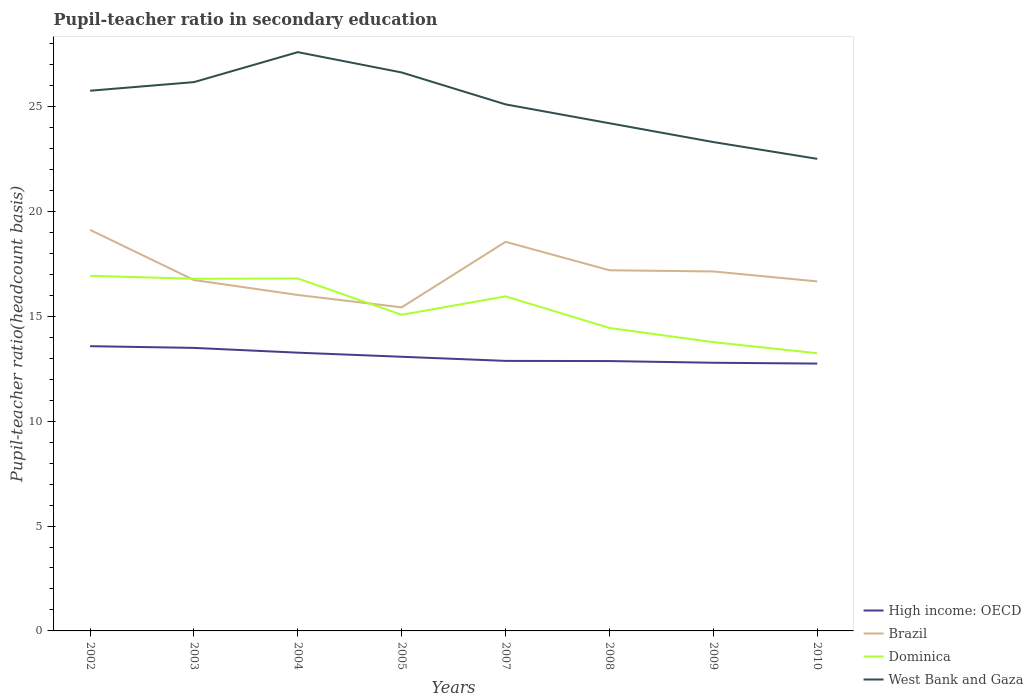How many different coloured lines are there?
Your answer should be very brief. 4. Across all years, what is the maximum pupil-teacher ratio in secondary education in Dominica?
Provide a succinct answer. 13.24. What is the total pupil-teacher ratio in secondary education in Dominica in the graph?
Your answer should be compact. 0.13. What is the difference between the highest and the second highest pupil-teacher ratio in secondary education in West Bank and Gaza?
Ensure brevity in your answer.  5.09. What is the difference between the highest and the lowest pupil-teacher ratio in secondary education in High income: OECD?
Provide a succinct answer. 3. How many lines are there?
Your answer should be very brief. 4. What is the difference between two consecutive major ticks on the Y-axis?
Offer a terse response. 5. Are the values on the major ticks of Y-axis written in scientific E-notation?
Ensure brevity in your answer.  No. What is the title of the graph?
Make the answer very short. Pupil-teacher ratio in secondary education. Does "Small states" appear as one of the legend labels in the graph?
Ensure brevity in your answer.  No. What is the label or title of the X-axis?
Offer a terse response. Years. What is the label or title of the Y-axis?
Keep it short and to the point. Pupil-teacher ratio(headcount basis). What is the Pupil-teacher ratio(headcount basis) of High income: OECD in 2002?
Provide a short and direct response. 13.58. What is the Pupil-teacher ratio(headcount basis) in Brazil in 2002?
Your answer should be compact. 19.12. What is the Pupil-teacher ratio(headcount basis) of Dominica in 2002?
Your answer should be very brief. 16.93. What is the Pupil-teacher ratio(headcount basis) in West Bank and Gaza in 2002?
Keep it short and to the point. 25.76. What is the Pupil-teacher ratio(headcount basis) in High income: OECD in 2003?
Your response must be concise. 13.49. What is the Pupil-teacher ratio(headcount basis) in Brazil in 2003?
Keep it short and to the point. 16.73. What is the Pupil-teacher ratio(headcount basis) of Dominica in 2003?
Keep it short and to the point. 16.79. What is the Pupil-teacher ratio(headcount basis) in West Bank and Gaza in 2003?
Provide a succinct answer. 26.17. What is the Pupil-teacher ratio(headcount basis) in High income: OECD in 2004?
Offer a very short reply. 13.27. What is the Pupil-teacher ratio(headcount basis) of Brazil in 2004?
Offer a terse response. 16.02. What is the Pupil-teacher ratio(headcount basis) of Dominica in 2004?
Your answer should be compact. 16.8. What is the Pupil-teacher ratio(headcount basis) in West Bank and Gaza in 2004?
Your response must be concise. 27.59. What is the Pupil-teacher ratio(headcount basis) in High income: OECD in 2005?
Your response must be concise. 13.07. What is the Pupil-teacher ratio(headcount basis) of Brazil in 2005?
Offer a very short reply. 15.43. What is the Pupil-teacher ratio(headcount basis) in Dominica in 2005?
Give a very brief answer. 15.07. What is the Pupil-teacher ratio(headcount basis) in West Bank and Gaza in 2005?
Your answer should be very brief. 26.63. What is the Pupil-teacher ratio(headcount basis) of High income: OECD in 2007?
Provide a succinct answer. 12.87. What is the Pupil-teacher ratio(headcount basis) of Brazil in 2007?
Your answer should be compact. 18.55. What is the Pupil-teacher ratio(headcount basis) in Dominica in 2007?
Ensure brevity in your answer.  15.95. What is the Pupil-teacher ratio(headcount basis) in West Bank and Gaza in 2007?
Offer a terse response. 25.1. What is the Pupil-teacher ratio(headcount basis) in High income: OECD in 2008?
Give a very brief answer. 12.87. What is the Pupil-teacher ratio(headcount basis) in Brazil in 2008?
Provide a succinct answer. 17.2. What is the Pupil-teacher ratio(headcount basis) of Dominica in 2008?
Your answer should be very brief. 14.44. What is the Pupil-teacher ratio(headcount basis) in West Bank and Gaza in 2008?
Provide a short and direct response. 24.2. What is the Pupil-teacher ratio(headcount basis) of High income: OECD in 2009?
Offer a terse response. 12.79. What is the Pupil-teacher ratio(headcount basis) in Brazil in 2009?
Your response must be concise. 17.14. What is the Pupil-teacher ratio(headcount basis) of Dominica in 2009?
Your answer should be compact. 13.77. What is the Pupil-teacher ratio(headcount basis) of West Bank and Gaza in 2009?
Your response must be concise. 23.31. What is the Pupil-teacher ratio(headcount basis) in High income: OECD in 2010?
Offer a very short reply. 12.75. What is the Pupil-teacher ratio(headcount basis) of Brazil in 2010?
Make the answer very short. 16.66. What is the Pupil-teacher ratio(headcount basis) of Dominica in 2010?
Make the answer very short. 13.24. What is the Pupil-teacher ratio(headcount basis) in West Bank and Gaza in 2010?
Your answer should be very brief. 22.51. Across all years, what is the maximum Pupil-teacher ratio(headcount basis) in High income: OECD?
Offer a very short reply. 13.58. Across all years, what is the maximum Pupil-teacher ratio(headcount basis) in Brazil?
Your answer should be very brief. 19.12. Across all years, what is the maximum Pupil-teacher ratio(headcount basis) in Dominica?
Ensure brevity in your answer.  16.93. Across all years, what is the maximum Pupil-teacher ratio(headcount basis) in West Bank and Gaza?
Your answer should be very brief. 27.59. Across all years, what is the minimum Pupil-teacher ratio(headcount basis) in High income: OECD?
Make the answer very short. 12.75. Across all years, what is the minimum Pupil-teacher ratio(headcount basis) in Brazil?
Keep it short and to the point. 15.43. Across all years, what is the minimum Pupil-teacher ratio(headcount basis) in Dominica?
Make the answer very short. 13.24. Across all years, what is the minimum Pupil-teacher ratio(headcount basis) in West Bank and Gaza?
Give a very brief answer. 22.51. What is the total Pupil-teacher ratio(headcount basis) of High income: OECD in the graph?
Make the answer very short. 104.68. What is the total Pupil-teacher ratio(headcount basis) in Brazil in the graph?
Offer a terse response. 136.85. What is the total Pupil-teacher ratio(headcount basis) of Dominica in the graph?
Your response must be concise. 123. What is the total Pupil-teacher ratio(headcount basis) in West Bank and Gaza in the graph?
Give a very brief answer. 201.27. What is the difference between the Pupil-teacher ratio(headcount basis) of High income: OECD in 2002 and that in 2003?
Your response must be concise. 0.08. What is the difference between the Pupil-teacher ratio(headcount basis) in Brazil in 2002 and that in 2003?
Ensure brevity in your answer.  2.39. What is the difference between the Pupil-teacher ratio(headcount basis) in Dominica in 2002 and that in 2003?
Provide a succinct answer. 0.14. What is the difference between the Pupil-teacher ratio(headcount basis) in West Bank and Gaza in 2002 and that in 2003?
Your response must be concise. -0.41. What is the difference between the Pupil-teacher ratio(headcount basis) in High income: OECD in 2002 and that in 2004?
Provide a short and direct response. 0.31. What is the difference between the Pupil-teacher ratio(headcount basis) in Brazil in 2002 and that in 2004?
Keep it short and to the point. 3.1. What is the difference between the Pupil-teacher ratio(headcount basis) in Dominica in 2002 and that in 2004?
Provide a succinct answer. 0.13. What is the difference between the Pupil-teacher ratio(headcount basis) in West Bank and Gaza in 2002 and that in 2004?
Keep it short and to the point. -1.84. What is the difference between the Pupil-teacher ratio(headcount basis) in High income: OECD in 2002 and that in 2005?
Provide a succinct answer. 0.5. What is the difference between the Pupil-teacher ratio(headcount basis) in Brazil in 2002 and that in 2005?
Your answer should be very brief. 3.69. What is the difference between the Pupil-teacher ratio(headcount basis) of Dominica in 2002 and that in 2005?
Ensure brevity in your answer.  1.86. What is the difference between the Pupil-teacher ratio(headcount basis) in West Bank and Gaza in 2002 and that in 2005?
Offer a very short reply. -0.87. What is the difference between the Pupil-teacher ratio(headcount basis) of High income: OECD in 2002 and that in 2007?
Give a very brief answer. 0.7. What is the difference between the Pupil-teacher ratio(headcount basis) of Brazil in 2002 and that in 2007?
Your answer should be compact. 0.57. What is the difference between the Pupil-teacher ratio(headcount basis) in Dominica in 2002 and that in 2007?
Keep it short and to the point. 0.98. What is the difference between the Pupil-teacher ratio(headcount basis) of West Bank and Gaza in 2002 and that in 2007?
Provide a short and direct response. 0.65. What is the difference between the Pupil-teacher ratio(headcount basis) in High income: OECD in 2002 and that in 2008?
Provide a short and direct response. 0.71. What is the difference between the Pupil-teacher ratio(headcount basis) in Brazil in 2002 and that in 2008?
Keep it short and to the point. 1.93. What is the difference between the Pupil-teacher ratio(headcount basis) of Dominica in 2002 and that in 2008?
Keep it short and to the point. 2.49. What is the difference between the Pupil-teacher ratio(headcount basis) of West Bank and Gaza in 2002 and that in 2008?
Your response must be concise. 1.55. What is the difference between the Pupil-teacher ratio(headcount basis) of High income: OECD in 2002 and that in 2009?
Your answer should be compact. 0.79. What is the difference between the Pupil-teacher ratio(headcount basis) of Brazil in 2002 and that in 2009?
Keep it short and to the point. 1.98. What is the difference between the Pupil-teacher ratio(headcount basis) of Dominica in 2002 and that in 2009?
Provide a short and direct response. 3.16. What is the difference between the Pupil-teacher ratio(headcount basis) of West Bank and Gaza in 2002 and that in 2009?
Ensure brevity in your answer.  2.45. What is the difference between the Pupil-teacher ratio(headcount basis) in High income: OECD in 2002 and that in 2010?
Ensure brevity in your answer.  0.83. What is the difference between the Pupil-teacher ratio(headcount basis) of Brazil in 2002 and that in 2010?
Your response must be concise. 2.46. What is the difference between the Pupil-teacher ratio(headcount basis) in Dominica in 2002 and that in 2010?
Ensure brevity in your answer.  3.69. What is the difference between the Pupil-teacher ratio(headcount basis) of West Bank and Gaza in 2002 and that in 2010?
Provide a short and direct response. 3.25. What is the difference between the Pupil-teacher ratio(headcount basis) of High income: OECD in 2003 and that in 2004?
Provide a short and direct response. 0.23. What is the difference between the Pupil-teacher ratio(headcount basis) in Brazil in 2003 and that in 2004?
Keep it short and to the point. 0.71. What is the difference between the Pupil-teacher ratio(headcount basis) in Dominica in 2003 and that in 2004?
Provide a succinct answer. -0.01. What is the difference between the Pupil-teacher ratio(headcount basis) of West Bank and Gaza in 2003 and that in 2004?
Ensure brevity in your answer.  -1.43. What is the difference between the Pupil-teacher ratio(headcount basis) of High income: OECD in 2003 and that in 2005?
Ensure brevity in your answer.  0.42. What is the difference between the Pupil-teacher ratio(headcount basis) in Brazil in 2003 and that in 2005?
Keep it short and to the point. 1.3. What is the difference between the Pupil-teacher ratio(headcount basis) of Dominica in 2003 and that in 2005?
Offer a terse response. 1.72. What is the difference between the Pupil-teacher ratio(headcount basis) of West Bank and Gaza in 2003 and that in 2005?
Offer a very short reply. -0.46. What is the difference between the Pupil-teacher ratio(headcount basis) in High income: OECD in 2003 and that in 2007?
Keep it short and to the point. 0.62. What is the difference between the Pupil-teacher ratio(headcount basis) in Brazil in 2003 and that in 2007?
Offer a very short reply. -1.82. What is the difference between the Pupil-teacher ratio(headcount basis) in Dominica in 2003 and that in 2007?
Your answer should be compact. 0.84. What is the difference between the Pupil-teacher ratio(headcount basis) of West Bank and Gaza in 2003 and that in 2007?
Give a very brief answer. 1.06. What is the difference between the Pupil-teacher ratio(headcount basis) in High income: OECD in 2003 and that in 2008?
Offer a very short reply. 0.63. What is the difference between the Pupil-teacher ratio(headcount basis) of Brazil in 2003 and that in 2008?
Offer a very short reply. -0.47. What is the difference between the Pupil-teacher ratio(headcount basis) of Dominica in 2003 and that in 2008?
Make the answer very short. 2.35. What is the difference between the Pupil-teacher ratio(headcount basis) of West Bank and Gaza in 2003 and that in 2008?
Provide a short and direct response. 1.96. What is the difference between the Pupil-teacher ratio(headcount basis) of High income: OECD in 2003 and that in 2009?
Ensure brevity in your answer.  0.71. What is the difference between the Pupil-teacher ratio(headcount basis) in Brazil in 2003 and that in 2009?
Offer a very short reply. -0.41. What is the difference between the Pupil-teacher ratio(headcount basis) of Dominica in 2003 and that in 2009?
Provide a succinct answer. 3.02. What is the difference between the Pupil-teacher ratio(headcount basis) of West Bank and Gaza in 2003 and that in 2009?
Make the answer very short. 2.86. What is the difference between the Pupil-teacher ratio(headcount basis) of High income: OECD in 2003 and that in 2010?
Make the answer very short. 0.75. What is the difference between the Pupil-teacher ratio(headcount basis) of Brazil in 2003 and that in 2010?
Give a very brief answer. 0.07. What is the difference between the Pupil-teacher ratio(headcount basis) in Dominica in 2003 and that in 2010?
Offer a very short reply. 3.55. What is the difference between the Pupil-teacher ratio(headcount basis) of West Bank and Gaza in 2003 and that in 2010?
Make the answer very short. 3.66. What is the difference between the Pupil-teacher ratio(headcount basis) of High income: OECD in 2004 and that in 2005?
Your answer should be compact. 0.2. What is the difference between the Pupil-teacher ratio(headcount basis) of Brazil in 2004 and that in 2005?
Offer a terse response. 0.59. What is the difference between the Pupil-teacher ratio(headcount basis) in Dominica in 2004 and that in 2005?
Provide a succinct answer. 1.73. What is the difference between the Pupil-teacher ratio(headcount basis) in West Bank and Gaza in 2004 and that in 2005?
Keep it short and to the point. 0.97. What is the difference between the Pupil-teacher ratio(headcount basis) of High income: OECD in 2004 and that in 2007?
Make the answer very short. 0.39. What is the difference between the Pupil-teacher ratio(headcount basis) in Brazil in 2004 and that in 2007?
Give a very brief answer. -2.53. What is the difference between the Pupil-teacher ratio(headcount basis) of Dominica in 2004 and that in 2007?
Give a very brief answer. 0.85. What is the difference between the Pupil-teacher ratio(headcount basis) of West Bank and Gaza in 2004 and that in 2007?
Provide a succinct answer. 2.49. What is the difference between the Pupil-teacher ratio(headcount basis) of High income: OECD in 2004 and that in 2008?
Keep it short and to the point. 0.4. What is the difference between the Pupil-teacher ratio(headcount basis) in Brazil in 2004 and that in 2008?
Your response must be concise. -1.18. What is the difference between the Pupil-teacher ratio(headcount basis) of Dominica in 2004 and that in 2008?
Keep it short and to the point. 2.36. What is the difference between the Pupil-teacher ratio(headcount basis) of West Bank and Gaza in 2004 and that in 2008?
Offer a terse response. 3.39. What is the difference between the Pupil-teacher ratio(headcount basis) in High income: OECD in 2004 and that in 2009?
Provide a succinct answer. 0.48. What is the difference between the Pupil-teacher ratio(headcount basis) of Brazil in 2004 and that in 2009?
Your answer should be compact. -1.12. What is the difference between the Pupil-teacher ratio(headcount basis) of Dominica in 2004 and that in 2009?
Your answer should be compact. 3.04. What is the difference between the Pupil-teacher ratio(headcount basis) in West Bank and Gaza in 2004 and that in 2009?
Offer a very short reply. 4.29. What is the difference between the Pupil-teacher ratio(headcount basis) in High income: OECD in 2004 and that in 2010?
Ensure brevity in your answer.  0.52. What is the difference between the Pupil-teacher ratio(headcount basis) of Brazil in 2004 and that in 2010?
Make the answer very short. -0.65. What is the difference between the Pupil-teacher ratio(headcount basis) in Dominica in 2004 and that in 2010?
Provide a short and direct response. 3.56. What is the difference between the Pupil-teacher ratio(headcount basis) of West Bank and Gaza in 2004 and that in 2010?
Your answer should be very brief. 5.09. What is the difference between the Pupil-teacher ratio(headcount basis) of High income: OECD in 2005 and that in 2007?
Your answer should be very brief. 0.2. What is the difference between the Pupil-teacher ratio(headcount basis) of Brazil in 2005 and that in 2007?
Provide a short and direct response. -3.12. What is the difference between the Pupil-teacher ratio(headcount basis) of Dominica in 2005 and that in 2007?
Provide a succinct answer. -0.88. What is the difference between the Pupil-teacher ratio(headcount basis) of West Bank and Gaza in 2005 and that in 2007?
Offer a very short reply. 1.52. What is the difference between the Pupil-teacher ratio(headcount basis) in High income: OECD in 2005 and that in 2008?
Offer a very short reply. 0.2. What is the difference between the Pupil-teacher ratio(headcount basis) of Brazil in 2005 and that in 2008?
Offer a very short reply. -1.77. What is the difference between the Pupil-teacher ratio(headcount basis) in Dominica in 2005 and that in 2008?
Keep it short and to the point. 0.63. What is the difference between the Pupil-teacher ratio(headcount basis) of West Bank and Gaza in 2005 and that in 2008?
Ensure brevity in your answer.  2.42. What is the difference between the Pupil-teacher ratio(headcount basis) of High income: OECD in 2005 and that in 2009?
Offer a very short reply. 0.28. What is the difference between the Pupil-teacher ratio(headcount basis) of Brazil in 2005 and that in 2009?
Offer a very short reply. -1.71. What is the difference between the Pupil-teacher ratio(headcount basis) of Dominica in 2005 and that in 2009?
Ensure brevity in your answer.  1.31. What is the difference between the Pupil-teacher ratio(headcount basis) of West Bank and Gaza in 2005 and that in 2009?
Offer a very short reply. 3.32. What is the difference between the Pupil-teacher ratio(headcount basis) of High income: OECD in 2005 and that in 2010?
Give a very brief answer. 0.32. What is the difference between the Pupil-teacher ratio(headcount basis) in Brazil in 2005 and that in 2010?
Provide a succinct answer. -1.24. What is the difference between the Pupil-teacher ratio(headcount basis) of Dominica in 2005 and that in 2010?
Offer a very short reply. 1.83. What is the difference between the Pupil-teacher ratio(headcount basis) of West Bank and Gaza in 2005 and that in 2010?
Keep it short and to the point. 4.12. What is the difference between the Pupil-teacher ratio(headcount basis) in High income: OECD in 2007 and that in 2008?
Offer a terse response. 0.01. What is the difference between the Pupil-teacher ratio(headcount basis) in Brazil in 2007 and that in 2008?
Offer a very short reply. 1.36. What is the difference between the Pupil-teacher ratio(headcount basis) in Dominica in 2007 and that in 2008?
Make the answer very short. 1.51. What is the difference between the Pupil-teacher ratio(headcount basis) of West Bank and Gaza in 2007 and that in 2008?
Offer a terse response. 0.9. What is the difference between the Pupil-teacher ratio(headcount basis) in High income: OECD in 2007 and that in 2009?
Your answer should be very brief. 0.09. What is the difference between the Pupil-teacher ratio(headcount basis) of Brazil in 2007 and that in 2009?
Offer a terse response. 1.41. What is the difference between the Pupil-teacher ratio(headcount basis) of Dominica in 2007 and that in 2009?
Your answer should be very brief. 2.18. What is the difference between the Pupil-teacher ratio(headcount basis) of West Bank and Gaza in 2007 and that in 2009?
Give a very brief answer. 1.8. What is the difference between the Pupil-teacher ratio(headcount basis) in High income: OECD in 2007 and that in 2010?
Provide a short and direct response. 0.13. What is the difference between the Pupil-teacher ratio(headcount basis) in Brazil in 2007 and that in 2010?
Your answer should be very brief. 1.89. What is the difference between the Pupil-teacher ratio(headcount basis) in Dominica in 2007 and that in 2010?
Make the answer very short. 2.71. What is the difference between the Pupil-teacher ratio(headcount basis) in West Bank and Gaza in 2007 and that in 2010?
Provide a short and direct response. 2.6. What is the difference between the Pupil-teacher ratio(headcount basis) of High income: OECD in 2008 and that in 2009?
Ensure brevity in your answer.  0.08. What is the difference between the Pupil-teacher ratio(headcount basis) in Brazil in 2008 and that in 2009?
Your response must be concise. 0.06. What is the difference between the Pupil-teacher ratio(headcount basis) in Dominica in 2008 and that in 2009?
Give a very brief answer. 0.68. What is the difference between the Pupil-teacher ratio(headcount basis) of West Bank and Gaza in 2008 and that in 2009?
Provide a succinct answer. 0.9. What is the difference between the Pupil-teacher ratio(headcount basis) in High income: OECD in 2008 and that in 2010?
Keep it short and to the point. 0.12. What is the difference between the Pupil-teacher ratio(headcount basis) of Brazil in 2008 and that in 2010?
Your answer should be compact. 0.53. What is the difference between the Pupil-teacher ratio(headcount basis) of Dominica in 2008 and that in 2010?
Provide a short and direct response. 1.2. What is the difference between the Pupil-teacher ratio(headcount basis) of West Bank and Gaza in 2008 and that in 2010?
Keep it short and to the point. 1.7. What is the difference between the Pupil-teacher ratio(headcount basis) of High income: OECD in 2009 and that in 2010?
Offer a very short reply. 0.04. What is the difference between the Pupil-teacher ratio(headcount basis) in Brazil in 2009 and that in 2010?
Your response must be concise. 0.47. What is the difference between the Pupil-teacher ratio(headcount basis) of Dominica in 2009 and that in 2010?
Ensure brevity in your answer.  0.53. What is the difference between the Pupil-teacher ratio(headcount basis) in West Bank and Gaza in 2009 and that in 2010?
Make the answer very short. 0.8. What is the difference between the Pupil-teacher ratio(headcount basis) in High income: OECD in 2002 and the Pupil-teacher ratio(headcount basis) in Brazil in 2003?
Make the answer very short. -3.15. What is the difference between the Pupil-teacher ratio(headcount basis) of High income: OECD in 2002 and the Pupil-teacher ratio(headcount basis) of Dominica in 2003?
Provide a succinct answer. -3.22. What is the difference between the Pupil-teacher ratio(headcount basis) in High income: OECD in 2002 and the Pupil-teacher ratio(headcount basis) in West Bank and Gaza in 2003?
Offer a very short reply. -12.59. What is the difference between the Pupil-teacher ratio(headcount basis) in Brazil in 2002 and the Pupil-teacher ratio(headcount basis) in Dominica in 2003?
Offer a terse response. 2.33. What is the difference between the Pupil-teacher ratio(headcount basis) of Brazil in 2002 and the Pupil-teacher ratio(headcount basis) of West Bank and Gaza in 2003?
Keep it short and to the point. -7.04. What is the difference between the Pupil-teacher ratio(headcount basis) of Dominica in 2002 and the Pupil-teacher ratio(headcount basis) of West Bank and Gaza in 2003?
Offer a very short reply. -9.24. What is the difference between the Pupil-teacher ratio(headcount basis) of High income: OECD in 2002 and the Pupil-teacher ratio(headcount basis) of Brazil in 2004?
Your answer should be very brief. -2.44. What is the difference between the Pupil-teacher ratio(headcount basis) in High income: OECD in 2002 and the Pupil-teacher ratio(headcount basis) in Dominica in 2004?
Keep it short and to the point. -3.23. What is the difference between the Pupil-teacher ratio(headcount basis) in High income: OECD in 2002 and the Pupil-teacher ratio(headcount basis) in West Bank and Gaza in 2004?
Your answer should be compact. -14.02. What is the difference between the Pupil-teacher ratio(headcount basis) of Brazil in 2002 and the Pupil-teacher ratio(headcount basis) of Dominica in 2004?
Give a very brief answer. 2.32. What is the difference between the Pupil-teacher ratio(headcount basis) of Brazil in 2002 and the Pupil-teacher ratio(headcount basis) of West Bank and Gaza in 2004?
Ensure brevity in your answer.  -8.47. What is the difference between the Pupil-teacher ratio(headcount basis) in Dominica in 2002 and the Pupil-teacher ratio(headcount basis) in West Bank and Gaza in 2004?
Give a very brief answer. -10.66. What is the difference between the Pupil-teacher ratio(headcount basis) of High income: OECD in 2002 and the Pupil-teacher ratio(headcount basis) of Brazil in 2005?
Your answer should be compact. -1.85. What is the difference between the Pupil-teacher ratio(headcount basis) of High income: OECD in 2002 and the Pupil-teacher ratio(headcount basis) of Dominica in 2005?
Ensure brevity in your answer.  -1.5. What is the difference between the Pupil-teacher ratio(headcount basis) in High income: OECD in 2002 and the Pupil-teacher ratio(headcount basis) in West Bank and Gaza in 2005?
Offer a terse response. -13.05. What is the difference between the Pupil-teacher ratio(headcount basis) in Brazil in 2002 and the Pupil-teacher ratio(headcount basis) in Dominica in 2005?
Give a very brief answer. 4.05. What is the difference between the Pupil-teacher ratio(headcount basis) of Brazil in 2002 and the Pupil-teacher ratio(headcount basis) of West Bank and Gaza in 2005?
Ensure brevity in your answer.  -7.5. What is the difference between the Pupil-teacher ratio(headcount basis) of Dominica in 2002 and the Pupil-teacher ratio(headcount basis) of West Bank and Gaza in 2005?
Your answer should be compact. -9.7. What is the difference between the Pupil-teacher ratio(headcount basis) in High income: OECD in 2002 and the Pupil-teacher ratio(headcount basis) in Brazil in 2007?
Ensure brevity in your answer.  -4.98. What is the difference between the Pupil-teacher ratio(headcount basis) in High income: OECD in 2002 and the Pupil-teacher ratio(headcount basis) in Dominica in 2007?
Make the answer very short. -2.38. What is the difference between the Pupil-teacher ratio(headcount basis) of High income: OECD in 2002 and the Pupil-teacher ratio(headcount basis) of West Bank and Gaza in 2007?
Your answer should be compact. -11.53. What is the difference between the Pupil-teacher ratio(headcount basis) of Brazil in 2002 and the Pupil-teacher ratio(headcount basis) of Dominica in 2007?
Keep it short and to the point. 3.17. What is the difference between the Pupil-teacher ratio(headcount basis) of Brazil in 2002 and the Pupil-teacher ratio(headcount basis) of West Bank and Gaza in 2007?
Keep it short and to the point. -5.98. What is the difference between the Pupil-teacher ratio(headcount basis) in Dominica in 2002 and the Pupil-teacher ratio(headcount basis) in West Bank and Gaza in 2007?
Your answer should be compact. -8.17. What is the difference between the Pupil-teacher ratio(headcount basis) of High income: OECD in 2002 and the Pupil-teacher ratio(headcount basis) of Brazil in 2008?
Offer a very short reply. -3.62. What is the difference between the Pupil-teacher ratio(headcount basis) of High income: OECD in 2002 and the Pupil-teacher ratio(headcount basis) of Dominica in 2008?
Your response must be concise. -0.87. What is the difference between the Pupil-teacher ratio(headcount basis) of High income: OECD in 2002 and the Pupil-teacher ratio(headcount basis) of West Bank and Gaza in 2008?
Provide a succinct answer. -10.63. What is the difference between the Pupil-teacher ratio(headcount basis) in Brazil in 2002 and the Pupil-teacher ratio(headcount basis) in Dominica in 2008?
Your answer should be compact. 4.68. What is the difference between the Pupil-teacher ratio(headcount basis) of Brazil in 2002 and the Pupil-teacher ratio(headcount basis) of West Bank and Gaza in 2008?
Give a very brief answer. -5.08. What is the difference between the Pupil-teacher ratio(headcount basis) in Dominica in 2002 and the Pupil-teacher ratio(headcount basis) in West Bank and Gaza in 2008?
Your response must be concise. -7.27. What is the difference between the Pupil-teacher ratio(headcount basis) of High income: OECD in 2002 and the Pupil-teacher ratio(headcount basis) of Brazil in 2009?
Provide a short and direct response. -3.56. What is the difference between the Pupil-teacher ratio(headcount basis) in High income: OECD in 2002 and the Pupil-teacher ratio(headcount basis) in Dominica in 2009?
Your answer should be compact. -0.19. What is the difference between the Pupil-teacher ratio(headcount basis) in High income: OECD in 2002 and the Pupil-teacher ratio(headcount basis) in West Bank and Gaza in 2009?
Provide a short and direct response. -9.73. What is the difference between the Pupil-teacher ratio(headcount basis) of Brazil in 2002 and the Pupil-teacher ratio(headcount basis) of Dominica in 2009?
Keep it short and to the point. 5.35. What is the difference between the Pupil-teacher ratio(headcount basis) in Brazil in 2002 and the Pupil-teacher ratio(headcount basis) in West Bank and Gaza in 2009?
Your answer should be compact. -4.19. What is the difference between the Pupil-teacher ratio(headcount basis) of Dominica in 2002 and the Pupil-teacher ratio(headcount basis) of West Bank and Gaza in 2009?
Give a very brief answer. -6.38. What is the difference between the Pupil-teacher ratio(headcount basis) in High income: OECD in 2002 and the Pupil-teacher ratio(headcount basis) in Brazil in 2010?
Offer a very short reply. -3.09. What is the difference between the Pupil-teacher ratio(headcount basis) in High income: OECD in 2002 and the Pupil-teacher ratio(headcount basis) in Dominica in 2010?
Provide a short and direct response. 0.34. What is the difference between the Pupil-teacher ratio(headcount basis) in High income: OECD in 2002 and the Pupil-teacher ratio(headcount basis) in West Bank and Gaza in 2010?
Ensure brevity in your answer.  -8.93. What is the difference between the Pupil-teacher ratio(headcount basis) in Brazil in 2002 and the Pupil-teacher ratio(headcount basis) in Dominica in 2010?
Offer a terse response. 5.88. What is the difference between the Pupil-teacher ratio(headcount basis) in Brazil in 2002 and the Pupil-teacher ratio(headcount basis) in West Bank and Gaza in 2010?
Ensure brevity in your answer.  -3.39. What is the difference between the Pupil-teacher ratio(headcount basis) of Dominica in 2002 and the Pupil-teacher ratio(headcount basis) of West Bank and Gaza in 2010?
Your answer should be compact. -5.58. What is the difference between the Pupil-teacher ratio(headcount basis) of High income: OECD in 2003 and the Pupil-teacher ratio(headcount basis) of Brazil in 2004?
Your answer should be compact. -2.52. What is the difference between the Pupil-teacher ratio(headcount basis) in High income: OECD in 2003 and the Pupil-teacher ratio(headcount basis) in Dominica in 2004?
Offer a very short reply. -3.31. What is the difference between the Pupil-teacher ratio(headcount basis) of High income: OECD in 2003 and the Pupil-teacher ratio(headcount basis) of West Bank and Gaza in 2004?
Offer a terse response. -14.1. What is the difference between the Pupil-teacher ratio(headcount basis) of Brazil in 2003 and the Pupil-teacher ratio(headcount basis) of Dominica in 2004?
Your answer should be compact. -0.07. What is the difference between the Pupil-teacher ratio(headcount basis) of Brazil in 2003 and the Pupil-teacher ratio(headcount basis) of West Bank and Gaza in 2004?
Provide a short and direct response. -10.86. What is the difference between the Pupil-teacher ratio(headcount basis) in Dominica in 2003 and the Pupil-teacher ratio(headcount basis) in West Bank and Gaza in 2004?
Ensure brevity in your answer.  -10.8. What is the difference between the Pupil-teacher ratio(headcount basis) in High income: OECD in 2003 and the Pupil-teacher ratio(headcount basis) in Brazil in 2005?
Keep it short and to the point. -1.93. What is the difference between the Pupil-teacher ratio(headcount basis) in High income: OECD in 2003 and the Pupil-teacher ratio(headcount basis) in Dominica in 2005?
Keep it short and to the point. -1.58. What is the difference between the Pupil-teacher ratio(headcount basis) of High income: OECD in 2003 and the Pupil-teacher ratio(headcount basis) of West Bank and Gaza in 2005?
Offer a terse response. -13.13. What is the difference between the Pupil-teacher ratio(headcount basis) in Brazil in 2003 and the Pupil-teacher ratio(headcount basis) in Dominica in 2005?
Offer a terse response. 1.66. What is the difference between the Pupil-teacher ratio(headcount basis) of Brazil in 2003 and the Pupil-teacher ratio(headcount basis) of West Bank and Gaza in 2005?
Offer a very short reply. -9.9. What is the difference between the Pupil-teacher ratio(headcount basis) in Dominica in 2003 and the Pupil-teacher ratio(headcount basis) in West Bank and Gaza in 2005?
Offer a terse response. -9.83. What is the difference between the Pupil-teacher ratio(headcount basis) in High income: OECD in 2003 and the Pupil-teacher ratio(headcount basis) in Brazil in 2007?
Keep it short and to the point. -5.06. What is the difference between the Pupil-teacher ratio(headcount basis) in High income: OECD in 2003 and the Pupil-teacher ratio(headcount basis) in Dominica in 2007?
Your answer should be compact. -2.46. What is the difference between the Pupil-teacher ratio(headcount basis) in High income: OECD in 2003 and the Pupil-teacher ratio(headcount basis) in West Bank and Gaza in 2007?
Your answer should be compact. -11.61. What is the difference between the Pupil-teacher ratio(headcount basis) of Brazil in 2003 and the Pupil-teacher ratio(headcount basis) of Dominica in 2007?
Your response must be concise. 0.78. What is the difference between the Pupil-teacher ratio(headcount basis) in Brazil in 2003 and the Pupil-teacher ratio(headcount basis) in West Bank and Gaza in 2007?
Give a very brief answer. -8.37. What is the difference between the Pupil-teacher ratio(headcount basis) of Dominica in 2003 and the Pupil-teacher ratio(headcount basis) of West Bank and Gaza in 2007?
Your response must be concise. -8.31. What is the difference between the Pupil-teacher ratio(headcount basis) in High income: OECD in 2003 and the Pupil-teacher ratio(headcount basis) in Brazil in 2008?
Offer a terse response. -3.7. What is the difference between the Pupil-teacher ratio(headcount basis) in High income: OECD in 2003 and the Pupil-teacher ratio(headcount basis) in Dominica in 2008?
Offer a very short reply. -0.95. What is the difference between the Pupil-teacher ratio(headcount basis) of High income: OECD in 2003 and the Pupil-teacher ratio(headcount basis) of West Bank and Gaza in 2008?
Your answer should be very brief. -10.71. What is the difference between the Pupil-teacher ratio(headcount basis) of Brazil in 2003 and the Pupil-teacher ratio(headcount basis) of Dominica in 2008?
Keep it short and to the point. 2.29. What is the difference between the Pupil-teacher ratio(headcount basis) in Brazil in 2003 and the Pupil-teacher ratio(headcount basis) in West Bank and Gaza in 2008?
Your answer should be very brief. -7.47. What is the difference between the Pupil-teacher ratio(headcount basis) of Dominica in 2003 and the Pupil-teacher ratio(headcount basis) of West Bank and Gaza in 2008?
Provide a succinct answer. -7.41. What is the difference between the Pupil-teacher ratio(headcount basis) of High income: OECD in 2003 and the Pupil-teacher ratio(headcount basis) of Brazil in 2009?
Give a very brief answer. -3.64. What is the difference between the Pupil-teacher ratio(headcount basis) in High income: OECD in 2003 and the Pupil-teacher ratio(headcount basis) in Dominica in 2009?
Your answer should be compact. -0.27. What is the difference between the Pupil-teacher ratio(headcount basis) of High income: OECD in 2003 and the Pupil-teacher ratio(headcount basis) of West Bank and Gaza in 2009?
Offer a terse response. -9.81. What is the difference between the Pupil-teacher ratio(headcount basis) of Brazil in 2003 and the Pupil-teacher ratio(headcount basis) of Dominica in 2009?
Offer a terse response. 2.96. What is the difference between the Pupil-teacher ratio(headcount basis) of Brazil in 2003 and the Pupil-teacher ratio(headcount basis) of West Bank and Gaza in 2009?
Provide a succinct answer. -6.58. What is the difference between the Pupil-teacher ratio(headcount basis) in Dominica in 2003 and the Pupil-teacher ratio(headcount basis) in West Bank and Gaza in 2009?
Your answer should be very brief. -6.52. What is the difference between the Pupil-teacher ratio(headcount basis) in High income: OECD in 2003 and the Pupil-teacher ratio(headcount basis) in Brazil in 2010?
Provide a short and direct response. -3.17. What is the difference between the Pupil-teacher ratio(headcount basis) in High income: OECD in 2003 and the Pupil-teacher ratio(headcount basis) in Dominica in 2010?
Your response must be concise. 0.25. What is the difference between the Pupil-teacher ratio(headcount basis) of High income: OECD in 2003 and the Pupil-teacher ratio(headcount basis) of West Bank and Gaza in 2010?
Make the answer very short. -9.01. What is the difference between the Pupil-teacher ratio(headcount basis) in Brazil in 2003 and the Pupil-teacher ratio(headcount basis) in Dominica in 2010?
Your answer should be compact. 3.49. What is the difference between the Pupil-teacher ratio(headcount basis) in Brazil in 2003 and the Pupil-teacher ratio(headcount basis) in West Bank and Gaza in 2010?
Your answer should be compact. -5.78. What is the difference between the Pupil-teacher ratio(headcount basis) in Dominica in 2003 and the Pupil-teacher ratio(headcount basis) in West Bank and Gaza in 2010?
Offer a terse response. -5.72. What is the difference between the Pupil-teacher ratio(headcount basis) in High income: OECD in 2004 and the Pupil-teacher ratio(headcount basis) in Brazil in 2005?
Your response must be concise. -2.16. What is the difference between the Pupil-teacher ratio(headcount basis) of High income: OECD in 2004 and the Pupil-teacher ratio(headcount basis) of Dominica in 2005?
Your answer should be very brief. -1.81. What is the difference between the Pupil-teacher ratio(headcount basis) in High income: OECD in 2004 and the Pupil-teacher ratio(headcount basis) in West Bank and Gaza in 2005?
Your answer should be compact. -13.36. What is the difference between the Pupil-teacher ratio(headcount basis) of Brazil in 2004 and the Pupil-teacher ratio(headcount basis) of Dominica in 2005?
Offer a terse response. 0.94. What is the difference between the Pupil-teacher ratio(headcount basis) of Brazil in 2004 and the Pupil-teacher ratio(headcount basis) of West Bank and Gaza in 2005?
Keep it short and to the point. -10.61. What is the difference between the Pupil-teacher ratio(headcount basis) of Dominica in 2004 and the Pupil-teacher ratio(headcount basis) of West Bank and Gaza in 2005?
Give a very brief answer. -9.82. What is the difference between the Pupil-teacher ratio(headcount basis) of High income: OECD in 2004 and the Pupil-teacher ratio(headcount basis) of Brazil in 2007?
Make the answer very short. -5.29. What is the difference between the Pupil-teacher ratio(headcount basis) of High income: OECD in 2004 and the Pupil-teacher ratio(headcount basis) of Dominica in 2007?
Ensure brevity in your answer.  -2.68. What is the difference between the Pupil-teacher ratio(headcount basis) of High income: OECD in 2004 and the Pupil-teacher ratio(headcount basis) of West Bank and Gaza in 2007?
Your answer should be compact. -11.84. What is the difference between the Pupil-teacher ratio(headcount basis) in Brazil in 2004 and the Pupil-teacher ratio(headcount basis) in Dominica in 2007?
Your answer should be compact. 0.07. What is the difference between the Pupil-teacher ratio(headcount basis) of Brazil in 2004 and the Pupil-teacher ratio(headcount basis) of West Bank and Gaza in 2007?
Provide a short and direct response. -9.09. What is the difference between the Pupil-teacher ratio(headcount basis) in Dominica in 2004 and the Pupil-teacher ratio(headcount basis) in West Bank and Gaza in 2007?
Give a very brief answer. -8.3. What is the difference between the Pupil-teacher ratio(headcount basis) in High income: OECD in 2004 and the Pupil-teacher ratio(headcount basis) in Brazil in 2008?
Provide a succinct answer. -3.93. What is the difference between the Pupil-teacher ratio(headcount basis) of High income: OECD in 2004 and the Pupil-teacher ratio(headcount basis) of Dominica in 2008?
Your response must be concise. -1.18. What is the difference between the Pupil-teacher ratio(headcount basis) of High income: OECD in 2004 and the Pupil-teacher ratio(headcount basis) of West Bank and Gaza in 2008?
Offer a very short reply. -10.94. What is the difference between the Pupil-teacher ratio(headcount basis) of Brazil in 2004 and the Pupil-teacher ratio(headcount basis) of Dominica in 2008?
Keep it short and to the point. 1.57. What is the difference between the Pupil-teacher ratio(headcount basis) of Brazil in 2004 and the Pupil-teacher ratio(headcount basis) of West Bank and Gaza in 2008?
Offer a very short reply. -8.19. What is the difference between the Pupil-teacher ratio(headcount basis) of Dominica in 2004 and the Pupil-teacher ratio(headcount basis) of West Bank and Gaza in 2008?
Provide a short and direct response. -7.4. What is the difference between the Pupil-teacher ratio(headcount basis) in High income: OECD in 2004 and the Pupil-teacher ratio(headcount basis) in Brazil in 2009?
Offer a terse response. -3.87. What is the difference between the Pupil-teacher ratio(headcount basis) in High income: OECD in 2004 and the Pupil-teacher ratio(headcount basis) in Dominica in 2009?
Offer a very short reply. -0.5. What is the difference between the Pupil-teacher ratio(headcount basis) in High income: OECD in 2004 and the Pupil-teacher ratio(headcount basis) in West Bank and Gaza in 2009?
Offer a terse response. -10.04. What is the difference between the Pupil-teacher ratio(headcount basis) of Brazil in 2004 and the Pupil-teacher ratio(headcount basis) of Dominica in 2009?
Ensure brevity in your answer.  2.25. What is the difference between the Pupil-teacher ratio(headcount basis) in Brazil in 2004 and the Pupil-teacher ratio(headcount basis) in West Bank and Gaza in 2009?
Your answer should be compact. -7.29. What is the difference between the Pupil-teacher ratio(headcount basis) in Dominica in 2004 and the Pupil-teacher ratio(headcount basis) in West Bank and Gaza in 2009?
Keep it short and to the point. -6.51. What is the difference between the Pupil-teacher ratio(headcount basis) in High income: OECD in 2004 and the Pupil-teacher ratio(headcount basis) in Brazil in 2010?
Your answer should be very brief. -3.4. What is the difference between the Pupil-teacher ratio(headcount basis) of High income: OECD in 2004 and the Pupil-teacher ratio(headcount basis) of Dominica in 2010?
Give a very brief answer. 0.03. What is the difference between the Pupil-teacher ratio(headcount basis) of High income: OECD in 2004 and the Pupil-teacher ratio(headcount basis) of West Bank and Gaza in 2010?
Your response must be concise. -9.24. What is the difference between the Pupil-teacher ratio(headcount basis) of Brazil in 2004 and the Pupil-teacher ratio(headcount basis) of Dominica in 2010?
Offer a very short reply. 2.78. What is the difference between the Pupil-teacher ratio(headcount basis) in Brazil in 2004 and the Pupil-teacher ratio(headcount basis) in West Bank and Gaza in 2010?
Provide a short and direct response. -6.49. What is the difference between the Pupil-teacher ratio(headcount basis) in Dominica in 2004 and the Pupil-teacher ratio(headcount basis) in West Bank and Gaza in 2010?
Provide a short and direct response. -5.71. What is the difference between the Pupil-teacher ratio(headcount basis) of High income: OECD in 2005 and the Pupil-teacher ratio(headcount basis) of Brazil in 2007?
Provide a short and direct response. -5.48. What is the difference between the Pupil-teacher ratio(headcount basis) in High income: OECD in 2005 and the Pupil-teacher ratio(headcount basis) in Dominica in 2007?
Offer a terse response. -2.88. What is the difference between the Pupil-teacher ratio(headcount basis) in High income: OECD in 2005 and the Pupil-teacher ratio(headcount basis) in West Bank and Gaza in 2007?
Your answer should be compact. -12.03. What is the difference between the Pupil-teacher ratio(headcount basis) in Brazil in 2005 and the Pupil-teacher ratio(headcount basis) in Dominica in 2007?
Your answer should be very brief. -0.52. What is the difference between the Pupil-teacher ratio(headcount basis) in Brazil in 2005 and the Pupil-teacher ratio(headcount basis) in West Bank and Gaza in 2007?
Give a very brief answer. -9.68. What is the difference between the Pupil-teacher ratio(headcount basis) in Dominica in 2005 and the Pupil-teacher ratio(headcount basis) in West Bank and Gaza in 2007?
Offer a terse response. -10.03. What is the difference between the Pupil-teacher ratio(headcount basis) of High income: OECD in 2005 and the Pupil-teacher ratio(headcount basis) of Brazil in 2008?
Offer a very short reply. -4.12. What is the difference between the Pupil-teacher ratio(headcount basis) of High income: OECD in 2005 and the Pupil-teacher ratio(headcount basis) of Dominica in 2008?
Offer a terse response. -1.37. What is the difference between the Pupil-teacher ratio(headcount basis) in High income: OECD in 2005 and the Pupil-teacher ratio(headcount basis) in West Bank and Gaza in 2008?
Keep it short and to the point. -11.13. What is the difference between the Pupil-teacher ratio(headcount basis) of Brazil in 2005 and the Pupil-teacher ratio(headcount basis) of Dominica in 2008?
Give a very brief answer. 0.98. What is the difference between the Pupil-teacher ratio(headcount basis) of Brazil in 2005 and the Pupil-teacher ratio(headcount basis) of West Bank and Gaza in 2008?
Your answer should be compact. -8.78. What is the difference between the Pupil-teacher ratio(headcount basis) of Dominica in 2005 and the Pupil-teacher ratio(headcount basis) of West Bank and Gaza in 2008?
Provide a short and direct response. -9.13. What is the difference between the Pupil-teacher ratio(headcount basis) of High income: OECD in 2005 and the Pupil-teacher ratio(headcount basis) of Brazil in 2009?
Provide a short and direct response. -4.07. What is the difference between the Pupil-teacher ratio(headcount basis) of High income: OECD in 2005 and the Pupil-teacher ratio(headcount basis) of Dominica in 2009?
Your answer should be very brief. -0.7. What is the difference between the Pupil-teacher ratio(headcount basis) in High income: OECD in 2005 and the Pupil-teacher ratio(headcount basis) in West Bank and Gaza in 2009?
Provide a succinct answer. -10.24. What is the difference between the Pupil-teacher ratio(headcount basis) of Brazil in 2005 and the Pupil-teacher ratio(headcount basis) of Dominica in 2009?
Your answer should be very brief. 1.66. What is the difference between the Pupil-teacher ratio(headcount basis) in Brazil in 2005 and the Pupil-teacher ratio(headcount basis) in West Bank and Gaza in 2009?
Ensure brevity in your answer.  -7.88. What is the difference between the Pupil-teacher ratio(headcount basis) of Dominica in 2005 and the Pupil-teacher ratio(headcount basis) of West Bank and Gaza in 2009?
Offer a very short reply. -8.24. What is the difference between the Pupil-teacher ratio(headcount basis) in High income: OECD in 2005 and the Pupil-teacher ratio(headcount basis) in Brazil in 2010?
Provide a short and direct response. -3.59. What is the difference between the Pupil-teacher ratio(headcount basis) of High income: OECD in 2005 and the Pupil-teacher ratio(headcount basis) of Dominica in 2010?
Your answer should be very brief. -0.17. What is the difference between the Pupil-teacher ratio(headcount basis) of High income: OECD in 2005 and the Pupil-teacher ratio(headcount basis) of West Bank and Gaza in 2010?
Offer a very short reply. -9.44. What is the difference between the Pupil-teacher ratio(headcount basis) of Brazil in 2005 and the Pupil-teacher ratio(headcount basis) of Dominica in 2010?
Make the answer very short. 2.19. What is the difference between the Pupil-teacher ratio(headcount basis) of Brazil in 2005 and the Pupil-teacher ratio(headcount basis) of West Bank and Gaza in 2010?
Make the answer very short. -7.08. What is the difference between the Pupil-teacher ratio(headcount basis) in Dominica in 2005 and the Pupil-teacher ratio(headcount basis) in West Bank and Gaza in 2010?
Keep it short and to the point. -7.44. What is the difference between the Pupil-teacher ratio(headcount basis) in High income: OECD in 2007 and the Pupil-teacher ratio(headcount basis) in Brazil in 2008?
Your response must be concise. -4.32. What is the difference between the Pupil-teacher ratio(headcount basis) of High income: OECD in 2007 and the Pupil-teacher ratio(headcount basis) of Dominica in 2008?
Offer a very short reply. -1.57. What is the difference between the Pupil-teacher ratio(headcount basis) of High income: OECD in 2007 and the Pupil-teacher ratio(headcount basis) of West Bank and Gaza in 2008?
Offer a terse response. -11.33. What is the difference between the Pupil-teacher ratio(headcount basis) of Brazil in 2007 and the Pupil-teacher ratio(headcount basis) of Dominica in 2008?
Offer a very short reply. 4.11. What is the difference between the Pupil-teacher ratio(headcount basis) of Brazil in 2007 and the Pupil-teacher ratio(headcount basis) of West Bank and Gaza in 2008?
Offer a terse response. -5.65. What is the difference between the Pupil-teacher ratio(headcount basis) of Dominica in 2007 and the Pupil-teacher ratio(headcount basis) of West Bank and Gaza in 2008?
Provide a succinct answer. -8.25. What is the difference between the Pupil-teacher ratio(headcount basis) of High income: OECD in 2007 and the Pupil-teacher ratio(headcount basis) of Brazil in 2009?
Offer a terse response. -4.26. What is the difference between the Pupil-teacher ratio(headcount basis) of High income: OECD in 2007 and the Pupil-teacher ratio(headcount basis) of Dominica in 2009?
Provide a succinct answer. -0.89. What is the difference between the Pupil-teacher ratio(headcount basis) of High income: OECD in 2007 and the Pupil-teacher ratio(headcount basis) of West Bank and Gaza in 2009?
Your answer should be compact. -10.43. What is the difference between the Pupil-teacher ratio(headcount basis) in Brazil in 2007 and the Pupil-teacher ratio(headcount basis) in Dominica in 2009?
Give a very brief answer. 4.78. What is the difference between the Pupil-teacher ratio(headcount basis) in Brazil in 2007 and the Pupil-teacher ratio(headcount basis) in West Bank and Gaza in 2009?
Keep it short and to the point. -4.76. What is the difference between the Pupil-teacher ratio(headcount basis) in Dominica in 2007 and the Pupil-teacher ratio(headcount basis) in West Bank and Gaza in 2009?
Offer a terse response. -7.36. What is the difference between the Pupil-teacher ratio(headcount basis) in High income: OECD in 2007 and the Pupil-teacher ratio(headcount basis) in Brazil in 2010?
Keep it short and to the point. -3.79. What is the difference between the Pupil-teacher ratio(headcount basis) in High income: OECD in 2007 and the Pupil-teacher ratio(headcount basis) in Dominica in 2010?
Make the answer very short. -0.37. What is the difference between the Pupil-teacher ratio(headcount basis) in High income: OECD in 2007 and the Pupil-teacher ratio(headcount basis) in West Bank and Gaza in 2010?
Offer a very short reply. -9.63. What is the difference between the Pupil-teacher ratio(headcount basis) of Brazil in 2007 and the Pupil-teacher ratio(headcount basis) of Dominica in 2010?
Offer a terse response. 5.31. What is the difference between the Pupil-teacher ratio(headcount basis) in Brazil in 2007 and the Pupil-teacher ratio(headcount basis) in West Bank and Gaza in 2010?
Ensure brevity in your answer.  -3.96. What is the difference between the Pupil-teacher ratio(headcount basis) in Dominica in 2007 and the Pupil-teacher ratio(headcount basis) in West Bank and Gaza in 2010?
Keep it short and to the point. -6.56. What is the difference between the Pupil-teacher ratio(headcount basis) of High income: OECD in 2008 and the Pupil-teacher ratio(headcount basis) of Brazil in 2009?
Your answer should be compact. -4.27. What is the difference between the Pupil-teacher ratio(headcount basis) of High income: OECD in 2008 and the Pupil-teacher ratio(headcount basis) of Dominica in 2009?
Offer a very short reply. -0.9. What is the difference between the Pupil-teacher ratio(headcount basis) of High income: OECD in 2008 and the Pupil-teacher ratio(headcount basis) of West Bank and Gaza in 2009?
Your answer should be very brief. -10.44. What is the difference between the Pupil-teacher ratio(headcount basis) in Brazil in 2008 and the Pupil-teacher ratio(headcount basis) in Dominica in 2009?
Keep it short and to the point. 3.43. What is the difference between the Pupil-teacher ratio(headcount basis) in Brazil in 2008 and the Pupil-teacher ratio(headcount basis) in West Bank and Gaza in 2009?
Offer a terse response. -6.11. What is the difference between the Pupil-teacher ratio(headcount basis) of Dominica in 2008 and the Pupil-teacher ratio(headcount basis) of West Bank and Gaza in 2009?
Offer a very short reply. -8.86. What is the difference between the Pupil-teacher ratio(headcount basis) of High income: OECD in 2008 and the Pupil-teacher ratio(headcount basis) of Brazil in 2010?
Provide a succinct answer. -3.8. What is the difference between the Pupil-teacher ratio(headcount basis) of High income: OECD in 2008 and the Pupil-teacher ratio(headcount basis) of Dominica in 2010?
Provide a short and direct response. -0.37. What is the difference between the Pupil-teacher ratio(headcount basis) in High income: OECD in 2008 and the Pupil-teacher ratio(headcount basis) in West Bank and Gaza in 2010?
Provide a short and direct response. -9.64. What is the difference between the Pupil-teacher ratio(headcount basis) of Brazil in 2008 and the Pupil-teacher ratio(headcount basis) of Dominica in 2010?
Your response must be concise. 3.95. What is the difference between the Pupil-teacher ratio(headcount basis) of Brazil in 2008 and the Pupil-teacher ratio(headcount basis) of West Bank and Gaza in 2010?
Your response must be concise. -5.31. What is the difference between the Pupil-teacher ratio(headcount basis) of Dominica in 2008 and the Pupil-teacher ratio(headcount basis) of West Bank and Gaza in 2010?
Your answer should be compact. -8.06. What is the difference between the Pupil-teacher ratio(headcount basis) of High income: OECD in 2009 and the Pupil-teacher ratio(headcount basis) of Brazil in 2010?
Keep it short and to the point. -3.88. What is the difference between the Pupil-teacher ratio(headcount basis) in High income: OECD in 2009 and the Pupil-teacher ratio(headcount basis) in Dominica in 2010?
Offer a terse response. -0.45. What is the difference between the Pupil-teacher ratio(headcount basis) of High income: OECD in 2009 and the Pupil-teacher ratio(headcount basis) of West Bank and Gaza in 2010?
Provide a succinct answer. -9.72. What is the difference between the Pupil-teacher ratio(headcount basis) in Brazil in 2009 and the Pupil-teacher ratio(headcount basis) in Dominica in 2010?
Offer a terse response. 3.9. What is the difference between the Pupil-teacher ratio(headcount basis) of Brazil in 2009 and the Pupil-teacher ratio(headcount basis) of West Bank and Gaza in 2010?
Your answer should be compact. -5.37. What is the difference between the Pupil-teacher ratio(headcount basis) of Dominica in 2009 and the Pupil-teacher ratio(headcount basis) of West Bank and Gaza in 2010?
Keep it short and to the point. -8.74. What is the average Pupil-teacher ratio(headcount basis) of High income: OECD per year?
Provide a short and direct response. 13.09. What is the average Pupil-teacher ratio(headcount basis) of Brazil per year?
Provide a short and direct response. 17.11. What is the average Pupil-teacher ratio(headcount basis) of Dominica per year?
Provide a short and direct response. 15.38. What is the average Pupil-teacher ratio(headcount basis) in West Bank and Gaza per year?
Offer a terse response. 25.16. In the year 2002, what is the difference between the Pupil-teacher ratio(headcount basis) in High income: OECD and Pupil-teacher ratio(headcount basis) in Brazil?
Your answer should be compact. -5.54. In the year 2002, what is the difference between the Pupil-teacher ratio(headcount basis) in High income: OECD and Pupil-teacher ratio(headcount basis) in Dominica?
Your response must be concise. -3.35. In the year 2002, what is the difference between the Pupil-teacher ratio(headcount basis) of High income: OECD and Pupil-teacher ratio(headcount basis) of West Bank and Gaza?
Provide a succinct answer. -12.18. In the year 2002, what is the difference between the Pupil-teacher ratio(headcount basis) of Brazil and Pupil-teacher ratio(headcount basis) of Dominica?
Give a very brief answer. 2.19. In the year 2002, what is the difference between the Pupil-teacher ratio(headcount basis) of Brazil and Pupil-teacher ratio(headcount basis) of West Bank and Gaza?
Give a very brief answer. -6.63. In the year 2002, what is the difference between the Pupil-teacher ratio(headcount basis) in Dominica and Pupil-teacher ratio(headcount basis) in West Bank and Gaza?
Keep it short and to the point. -8.83. In the year 2003, what is the difference between the Pupil-teacher ratio(headcount basis) of High income: OECD and Pupil-teacher ratio(headcount basis) of Brazil?
Provide a short and direct response. -3.24. In the year 2003, what is the difference between the Pupil-teacher ratio(headcount basis) in High income: OECD and Pupil-teacher ratio(headcount basis) in Dominica?
Keep it short and to the point. -3.3. In the year 2003, what is the difference between the Pupil-teacher ratio(headcount basis) of High income: OECD and Pupil-teacher ratio(headcount basis) of West Bank and Gaza?
Give a very brief answer. -12.67. In the year 2003, what is the difference between the Pupil-teacher ratio(headcount basis) of Brazil and Pupil-teacher ratio(headcount basis) of Dominica?
Ensure brevity in your answer.  -0.06. In the year 2003, what is the difference between the Pupil-teacher ratio(headcount basis) of Brazil and Pupil-teacher ratio(headcount basis) of West Bank and Gaza?
Ensure brevity in your answer.  -9.44. In the year 2003, what is the difference between the Pupil-teacher ratio(headcount basis) of Dominica and Pupil-teacher ratio(headcount basis) of West Bank and Gaza?
Your answer should be very brief. -9.37. In the year 2004, what is the difference between the Pupil-teacher ratio(headcount basis) in High income: OECD and Pupil-teacher ratio(headcount basis) in Brazil?
Your response must be concise. -2.75. In the year 2004, what is the difference between the Pupil-teacher ratio(headcount basis) of High income: OECD and Pupil-teacher ratio(headcount basis) of Dominica?
Provide a succinct answer. -3.54. In the year 2004, what is the difference between the Pupil-teacher ratio(headcount basis) of High income: OECD and Pupil-teacher ratio(headcount basis) of West Bank and Gaza?
Your answer should be very brief. -14.33. In the year 2004, what is the difference between the Pupil-teacher ratio(headcount basis) in Brazil and Pupil-teacher ratio(headcount basis) in Dominica?
Your answer should be very brief. -0.79. In the year 2004, what is the difference between the Pupil-teacher ratio(headcount basis) in Brazil and Pupil-teacher ratio(headcount basis) in West Bank and Gaza?
Offer a terse response. -11.58. In the year 2004, what is the difference between the Pupil-teacher ratio(headcount basis) of Dominica and Pupil-teacher ratio(headcount basis) of West Bank and Gaza?
Keep it short and to the point. -10.79. In the year 2005, what is the difference between the Pupil-teacher ratio(headcount basis) in High income: OECD and Pupil-teacher ratio(headcount basis) in Brazil?
Your answer should be compact. -2.36. In the year 2005, what is the difference between the Pupil-teacher ratio(headcount basis) of High income: OECD and Pupil-teacher ratio(headcount basis) of Dominica?
Your response must be concise. -2. In the year 2005, what is the difference between the Pupil-teacher ratio(headcount basis) of High income: OECD and Pupil-teacher ratio(headcount basis) of West Bank and Gaza?
Provide a short and direct response. -13.55. In the year 2005, what is the difference between the Pupil-teacher ratio(headcount basis) in Brazil and Pupil-teacher ratio(headcount basis) in Dominica?
Your response must be concise. 0.36. In the year 2005, what is the difference between the Pupil-teacher ratio(headcount basis) of Brazil and Pupil-teacher ratio(headcount basis) of West Bank and Gaza?
Keep it short and to the point. -11.2. In the year 2005, what is the difference between the Pupil-teacher ratio(headcount basis) of Dominica and Pupil-teacher ratio(headcount basis) of West Bank and Gaza?
Your response must be concise. -11.55. In the year 2007, what is the difference between the Pupil-teacher ratio(headcount basis) in High income: OECD and Pupil-teacher ratio(headcount basis) in Brazil?
Keep it short and to the point. -5.68. In the year 2007, what is the difference between the Pupil-teacher ratio(headcount basis) of High income: OECD and Pupil-teacher ratio(headcount basis) of Dominica?
Make the answer very short. -3.08. In the year 2007, what is the difference between the Pupil-teacher ratio(headcount basis) of High income: OECD and Pupil-teacher ratio(headcount basis) of West Bank and Gaza?
Provide a short and direct response. -12.23. In the year 2007, what is the difference between the Pupil-teacher ratio(headcount basis) in Brazil and Pupil-teacher ratio(headcount basis) in Dominica?
Make the answer very short. 2.6. In the year 2007, what is the difference between the Pupil-teacher ratio(headcount basis) in Brazil and Pupil-teacher ratio(headcount basis) in West Bank and Gaza?
Keep it short and to the point. -6.55. In the year 2007, what is the difference between the Pupil-teacher ratio(headcount basis) of Dominica and Pupil-teacher ratio(headcount basis) of West Bank and Gaza?
Your answer should be compact. -9.15. In the year 2008, what is the difference between the Pupil-teacher ratio(headcount basis) in High income: OECD and Pupil-teacher ratio(headcount basis) in Brazil?
Provide a succinct answer. -4.33. In the year 2008, what is the difference between the Pupil-teacher ratio(headcount basis) in High income: OECD and Pupil-teacher ratio(headcount basis) in Dominica?
Offer a very short reply. -1.58. In the year 2008, what is the difference between the Pupil-teacher ratio(headcount basis) of High income: OECD and Pupil-teacher ratio(headcount basis) of West Bank and Gaza?
Your response must be concise. -11.34. In the year 2008, what is the difference between the Pupil-teacher ratio(headcount basis) in Brazil and Pupil-teacher ratio(headcount basis) in Dominica?
Your answer should be compact. 2.75. In the year 2008, what is the difference between the Pupil-teacher ratio(headcount basis) in Brazil and Pupil-teacher ratio(headcount basis) in West Bank and Gaza?
Your response must be concise. -7.01. In the year 2008, what is the difference between the Pupil-teacher ratio(headcount basis) in Dominica and Pupil-teacher ratio(headcount basis) in West Bank and Gaza?
Offer a very short reply. -9.76. In the year 2009, what is the difference between the Pupil-teacher ratio(headcount basis) of High income: OECD and Pupil-teacher ratio(headcount basis) of Brazil?
Keep it short and to the point. -4.35. In the year 2009, what is the difference between the Pupil-teacher ratio(headcount basis) in High income: OECD and Pupil-teacher ratio(headcount basis) in Dominica?
Your answer should be compact. -0.98. In the year 2009, what is the difference between the Pupil-teacher ratio(headcount basis) in High income: OECD and Pupil-teacher ratio(headcount basis) in West Bank and Gaza?
Ensure brevity in your answer.  -10.52. In the year 2009, what is the difference between the Pupil-teacher ratio(headcount basis) of Brazil and Pupil-teacher ratio(headcount basis) of Dominica?
Provide a short and direct response. 3.37. In the year 2009, what is the difference between the Pupil-teacher ratio(headcount basis) in Brazil and Pupil-teacher ratio(headcount basis) in West Bank and Gaza?
Your response must be concise. -6.17. In the year 2009, what is the difference between the Pupil-teacher ratio(headcount basis) in Dominica and Pupil-teacher ratio(headcount basis) in West Bank and Gaza?
Your answer should be very brief. -9.54. In the year 2010, what is the difference between the Pupil-teacher ratio(headcount basis) of High income: OECD and Pupil-teacher ratio(headcount basis) of Brazil?
Ensure brevity in your answer.  -3.92. In the year 2010, what is the difference between the Pupil-teacher ratio(headcount basis) of High income: OECD and Pupil-teacher ratio(headcount basis) of Dominica?
Keep it short and to the point. -0.49. In the year 2010, what is the difference between the Pupil-teacher ratio(headcount basis) in High income: OECD and Pupil-teacher ratio(headcount basis) in West Bank and Gaza?
Offer a terse response. -9.76. In the year 2010, what is the difference between the Pupil-teacher ratio(headcount basis) in Brazil and Pupil-teacher ratio(headcount basis) in Dominica?
Keep it short and to the point. 3.42. In the year 2010, what is the difference between the Pupil-teacher ratio(headcount basis) of Brazil and Pupil-teacher ratio(headcount basis) of West Bank and Gaza?
Make the answer very short. -5.84. In the year 2010, what is the difference between the Pupil-teacher ratio(headcount basis) in Dominica and Pupil-teacher ratio(headcount basis) in West Bank and Gaza?
Your answer should be compact. -9.27. What is the ratio of the Pupil-teacher ratio(headcount basis) in Brazil in 2002 to that in 2003?
Offer a terse response. 1.14. What is the ratio of the Pupil-teacher ratio(headcount basis) in Dominica in 2002 to that in 2003?
Keep it short and to the point. 1.01. What is the ratio of the Pupil-teacher ratio(headcount basis) in West Bank and Gaza in 2002 to that in 2003?
Make the answer very short. 0.98. What is the ratio of the Pupil-teacher ratio(headcount basis) of High income: OECD in 2002 to that in 2004?
Make the answer very short. 1.02. What is the ratio of the Pupil-teacher ratio(headcount basis) in Brazil in 2002 to that in 2004?
Ensure brevity in your answer.  1.19. What is the ratio of the Pupil-teacher ratio(headcount basis) in Dominica in 2002 to that in 2004?
Keep it short and to the point. 1.01. What is the ratio of the Pupil-teacher ratio(headcount basis) in West Bank and Gaza in 2002 to that in 2004?
Your answer should be compact. 0.93. What is the ratio of the Pupil-teacher ratio(headcount basis) in High income: OECD in 2002 to that in 2005?
Provide a succinct answer. 1.04. What is the ratio of the Pupil-teacher ratio(headcount basis) of Brazil in 2002 to that in 2005?
Your response must be concise. 1.24. What is the ratio of the Pupil-teacher ratio(headcount basis) in Dominica in 2002 to that in 2005?
Your response must be concise. 1.12. What is the ratio of the Pupil-teacher ratio(headcount basis) of West Bank and Gaza in 2002 to that in 2005?
Offer a terse response. 0.97. What is the ratio of the Pupil-teacher ratio(headcount basis) of High income: OECD in 2002 to that in 2007?
Make the answer very short. 1.05. What is the ratio of the Pupil-teacher ratio(headcount basis) of Brazil in 2002 to that in 2007?
Your answer should be very brief. 1.03. What is the ratio of the Pupil-teacher ratio(headcount basis) in Dominica in 2002 to that in 2007?
Offer a very short reply. 1.06. What is the ratio of the Pupil-teacher ratio(headcount basis) in West Bank and Gaza in 2002 to that in 2007?
Your answer should be very brief. 1.03. What is the ratio of the Pupil-teacher ratio(headcount basis) in High income: OECD in 2002 to that in 2008?
Your answer should be compact. 1.06. What is the ratio of the Pupil-teacher ratio(headcount basis) of Brazil in 2002 to that in 2008?
Keep it short and to the point. 1.11. What is the ratio of the Pupil-teacher ratio(headcount basis) in Dominica in 2002 to that in 2008?
Make the answer very short. 1.17. What is the ratio of the Pupil-teacher ratio(headcount basis) of West Bank and Gaza in 2002 to that in 2008?
Your response must be concise. 1.06. What is the ratio of the Pupil-teacher ratio(headcount basis) in High income: OECD in 2002 to that in 2009?
Make the answer very short. 1.06. What is the ratio of the Pupil-teacher ratio(headcount basis) in Brazil in 2002 to that in 2009?
Your answer should be compact. 1.12. What is the ratio of the Pupil-teacher ratio(headcount basis) of Dominica in 2002 to that in 2009?
Provide a short and direct response. 1.23. What is the ratio of the Pupil-teacher ratio(headcount basis) in West Bank and Gaza in 2002 to that in 2009?
Your answer should be compact. 1.1. What is the ratio of the Pupil-teacher ratio(headcount basis) of High income: OECD in 2002 to that in 2010?
Ensure brevity in your answer.  1.07. What is the ratio of the Pupil-teacher ratio(headcount basis) in Brazil in 2002 to that in 2010?
Give a very brief answer. 1.15. What is the ratio of the Pupil-teacher ratio(headcount basis) in Dominica in 2002 to that in 2010?
Give a very brief answer. 1.28. What is the ratio of the Pupil-teacher ratio(headcount basis) in West Bank and Gaza in 2002 to that in 2010?
Offer a very short reply. 1.14. What is the ratio of the Pupil-teacher ratio(headcount basis) in High income: OECD in 2003 to that in 2004?
Your answer should be compact. 1.02. What is the ratio of the Pupil-teacher ratio(headcount basis) in Brazil in 2003 to that in 2004?
Provide a short and direct response. 1.04. What is the ratio of the Pupil-teacher ratio(headcount basis) of Dominica in 2003 to that in 2004?
Offer a very short reply. 1. What is the ratio of the Pupil-teacher ratio(headcount basis) of West Bank and Gaza in 2003 to that in 2004?
Give a very brief answer. 0.95. What is the ratio of the Pupil-teacher ratio(headcount basis) in High income: OECD in 2003 to that in 2005?
Your answer should be very brief. 1.03. What is the ratio of the Pupil-teacher ratio(headcount basis) of Brazil in 2003 to that in 2005?
Offer a very short reply. 1.08. What is the ratio of the Pupil-teacher ratio(headcount basis) of Dominica in 2003 to that in 2005?
Your answer should be compact. 1.11. What is the ratio of the Pupil-teacher ratio(headcount basis) in West Bank and Gaza in 2003 to that in 2005?
Provide a short and direct response. 0.98. What is the ratio of the Pupil-teacher ratio(headcount basis) in High income: OECD in 2003 to that in 2007?
Provide a succinct answer. 1.05. What is the ratio of the Pupil-teacher ratio(headcount basis) in Brazil in 2003 to that in 2007?
Your answer should be very brief. 0.9. What is the ratio of the Pupil-teacher ratio(headcount basis) of Dominica in 2003 to that in 2007?
Provide a short and direct response. 1.05. What is the ratio of the Pupil-teacher ratio(headcount basis) of West Bank and Gaza in 2003 to that in 2007?
Give a very brief answer. 1.04. What is the ratio of the Pupil-teacher ratio(headcount basis) in High income: OECD in 2003 to that in 2008?
Keep it short and to the point. 1.05. What is the ratio of the Pupil-teacher ratio(headcount basis) in Brazil in 2003 to that in 2008?
Provide a succinct answer. 0.97. What is the ratio of the Pupil-teacher ratio(headcount basis) in Dominica in 2003 to that in 2008?
Your response must be concise. 1.16. What is the ratio of the Pupil-teacher ratio(headcount basis) of West Bank and Gaza in 2003 to that in 2008?
Give a very brief answer. 1.08. What is the ratio of the Pupil-teacher ratio(headcount basis) in High income: OECD in 2003 to that in 2009?
Offer a very short reply. 1.06. What is the ratio of the Pupil-teacher ratio(headcount basis) of Brazil in 2003 to that in 2009?
Your answer should be very brief. 0.98. What is the ratio of the Pupil-teacher ratio(headcount basis) in Dominica in 2003 to that in 2009?
Ensure brevity in your answer.  1.22. What is the ratio of the Pupil-teacher ratio(headcount basis) of West Bank and Gaza in 2003 to that in 2009?
Provide a short and direct response. 1.12. What is the ratio of the Pupil-teacher ratio(headcount basis) of High income: OECD in 2003 to that in 2010?
Ensure brevity in your answer.  1.06. What is the ratio of the Pupil-teacher ratio(headcount basis) of Dominica in 2003 to that in 2010?
Make the answer very short. 1.27. What is the ratio of the Pupil-teacher ratio(headcount basis) in West Bank and Gaza in 2003 to that in 2010?
Provide a short and direct response. 1.16. What is the ratio of the Pupil-teacher ratio(headcount basis) in High income: OECD in 2004 to that in 2005?
Your answer should be compact. 1.01. What is the ratio of the Pupil-teacher ratio(headcount basis) in Brazil in 2004 to that in 2005?
Ensure brevity in your answer.  1.04. What is the ratio of the Pupil-teacher ratio(headcount basis) of Dominica in 2004 to that in 2005?
Provide a succinct answer. 1.11. What is the ratio of the Pupil-teacher ratio(headcount basis) of West Bank and Gaza in 2004 to that in 2005?
Your answer should be very brief. 1.04. What is the ratio of the Pupil-teacher ratio(headcount basis) of High income: OECD in 2004 to that in 2007?
Offer a very short reply. 1.03. What is the ratio of the Pupil-teacher ratio(headcount basis) in Brazil in 2004 to that in 2007?
Make the answer very short. 0.86. What is the ratio of the Pupil-teacher ratio(headcount basis) in Dominica in 2004 to that in 2007?
Make the answer very short. 1.05. What is the ratio of the Pupil-teacher ratio(headcount basis) in West Bank and Gaza in 2004 to that in 2007?
Offer a very short reply. 1.1. What is the ratio of the Pupil-teacher ratio(headcount basis) of High income: OECD in 2004 to that in 2008?
Ensure brevity in your answer.  1.03. What is the ratio of the Pupil-teacher ratio(headcount basis) in Brazil in 2004 to that in 2008?
Make the answer very short. 0.93. What is the ratio of the Pupil-teacher ratio(headcount basis) in Dominica in 2004 to that in 2008?
Make the answer very short. 1.16. What is the ratio of the Pupil-teacher ratio(headcount basis) of West Bank and Gaza in 2004 to that in 2008?
Your answer should be very brief. 1.14. What is the ratio of the Pupil-teacher ratio(headcount basis) of High income: OECD in 2004 to that in 2009?
Make the answer very short. 1.04. What is the ratio of the Pupil-teacher ratio(headcount basis) in Brazil in 2004 to that in 2009?
Ensure brevity in your answer.  0.93. What is the ratio of the Pupil-teacher ratio(headcount basis) in Dominica in 2004 to that in 2009?
Provide a short and direct response. 1.22. What is the ratio of the Pupil-teacher ratio(headcount basis) of West Bank and Gaza in 2004 to that in 2009?
Your answer should be compact. 1.18. What is the ratio of the Pupil-teacher ratio(headcount basis) of High income: OECD in 2004 to that in 2010?
Your response must be concise. 1.04. What is the ratio of the Pupil-teacher ratio(headcount basis) in Brazil in 2004 to that in 2010?
Your answer should be very brief. 0.96. What is the ratio of the Pupil-teacher ratio(headcount basis) of Dominica in 2004 to that in 2010?
Keep it short and to the point. 1.27. What is the ratio of the Pupil-teacher ratio(headcount basis) of West Bank and Gaza in 2004 to that in 2010?
Offer a very short reply. 1.23. What is the ratio of the Pupil-teacher ratio(headcount basis) of High income: OECD in 2005 to that in 2007?
Your response must be concise. 1.02. What is the ratio of the Pupil-teacher ratio(headcount basis) in Brazil in 2005 to that in 2007?
Offer a very short reply. 0.83. What is the ratio of the Pupil-teacher ratio(headcount basis) in Dominica in 2005 to that in 2007?
Your answer should be very brief. 0.94. What is the ratio of the Pupil-teacher ratio(headcount basis) in West Bank and Gaza in 2005 to that in 2007?
Your answer should be very brief. 1.06. What is the ratio of the Pupil-teacher ratio(headcount basis) of High income: OECD in 2005 to that in 2008?
Provide a succinct answer. 1.02. What is the ratio of the Pupil-teacher ratio(headcount basis) of Brazil in 2005 to that in 2008?
Offer a very short reply. 0.9. What is the ratio of the Pupil-teacher ratio(headcount basis) of Dominica in 2005 to that in 2008?
Your response must be concise. 1.04. What is the ratio of the Pupil-teacher ratio(headcount basis) in High income: OECD in 2005 to that in 2009?
Keep it short and to the point. 1.02. What is the ratio of the Pupil-teacher ratio(headcount basis) in Brazil in 2005 to that in 2009?
Keep it short and to the point. 0.9. What is the ratio of the Pupil-teacher ratio(headcount basis) of Dominica in 2005 to that in 2009?
Offer a very short reply. 1.09. What is the ratio of the Pupil-teacher ratio(headcount basis) in West Bank and Gaza in 2005 to that in 2009?
Give a very brief answer. 1.14. What is the ratio of the Pupil-teacher ratio(headcount basis) of High income: OECD in 2005 to that in 2010?
Offer a terse response. 1.03. What is the ratio of the Pupil-teacher ratio(headcount basis) in Brazil in 2005 to that in 2010?
Offer a terse response. 0.93. What is the ratio of the Pupil-teacher ratio(headcount basis) of Dominica in 2005 to that in 2010?
Keep it short and to the point. 1.14. What is the ratio of the Pupil-teacher ratio(headcount basis) of West Bank and Gaza in 2005 to that in 2010?
Your answer should be very brief. 1.18. What is the ratio of the Pupil-teacher ratio(headcount basis) of Brazil in 2007 to that in 2008?
Ensure brevity in your answer.  1.08. What is the ratio of the Pupil-teacher ratio(headcount basis) of Dominica in 2007 to that in 2008?
Ensure brevity in your answer.  1.1. What is the ratio of the Pupil-teacher ratio(headcount basis) of West Bank and Gaza in 2007 to that in 2008?
Give a very brief answer. 1.04. What is the ratio of the Pupil-teacher ratio(headcount basis) in Brazil in 2007 to that in 2009?
Keep it short and to the point. 1.08. What is the ratio of the Pupil-teacher ratio(headcount basis) in Dominica in 2007 to that in 2009?
Offer a very short reply. 1.16. What is the ratio of the Pupil-teacher ratio(headcount basis) in West Bank and Gaza in 2007 to that in 2009?
Your answer should be very brief. 1.08. What is the ratio of the Pupil-teacher ratio(headcount basis) of Brazil in 2007 to that in 2010?
Offer a very short reply. 1.11. What is the ratio of the Pupil-teacher ratio(headcount basis) in Dominica in 2007 to that in 2010?
Provide a succinct answer. 1.2. What is the ratio of the Pupil-teacher ratio(headcount basis) in West Bank and Gaza in 2007 to that in 2010?
Keep it short and to the point. 1.12. What is the ratio of the Pupil-teacher ratio(headcount basis) of Dominica in 2008 to that in 2009?
Your response must be concise. 1.05. What is the ratio of the Pupil-teacher ratio(headcount basis) of West Bank and Gaza in 2008 to that in 2009?
Give a very brief answer. 1.04. What is the ratio of the Pupil-teacher ratio(headcount basis) of High income: OECD in 2008 to that in 2010?
Provide a succinct answer. 1.01. What is the ratio of the Pupil-teacher ratio(headcount basis) of Brazil in 2008 to that in 2010?
Your answer should be compact. 1.03. What is the ratio of the Pupil-teacher ratio(headcount basis) in Dominica in 2008 to that in 2010?
Offer a very short reply. 1.09. What is the ratio of the Pupil-teacher ratio(headcount basis) of West Bank and Gaza in 2008 to that in 2010?
Ensure brevity in your answer.  1.08. What is the ratio of the Pupil-teacher ratio(headcount basis) in High income: OECD in 2009 to that in 2010?
Your response must be concise. 1. What is the ratio of the Pupil-teacher ratio(headcount basis) of Brazil in 2009 to that in 2010?
Your answer should be compact. 1.03. What is the ratio of the Pupil-teacher ratio(headcount basis) in Dominica in 2009 to that in 2010?
Your answer should be very brief. 1.04. What is the ratio of the Pupil-teacher ratio(headcount basis) of West Bank and Gaza in 2009 to that in 2010?
Offer a very short reply. 1.04. What is the difference between the highest and the second highest Pupil-teacher ratio(headcount basis) of High income: OECD?
Offer a very short reply. 0.08. What is the difference between the highest and the second highest Pupil-teacher ratio(headcount basis) in Brazil?
Provide a short and direct response. 0.57. What is the difference between the highest and the second highest Pupil-teacher ratio(headcount basis) of Dominica?
Make the answer very short. 0.13. What is the difference between the highest and the second highest Pupil-teacher ratio(headcount basis) in West Bank and Gaza?
Give a very brief answer. 0.97. What is the difference between the highest and the lowest Pupil-teacher ratio(headcount basis) of High income: OECD?
Keep it short and to the point. 0.83. What is the difference between the highest and the lowest Pupil-teacher ratio(headcount basis) in Brazil?
Make the answer very short. 3.69. What is the difference between the highest and the lowest Pupil-teacher ratio(headcount basis) of Dominica?
Provide a short and direct response. 3.69. What is the difference between the highest and the lowest Pupil-teacher ratio(headcount basis) of West Bank and Gaza?
Provide a short and direct response. 5.09. 